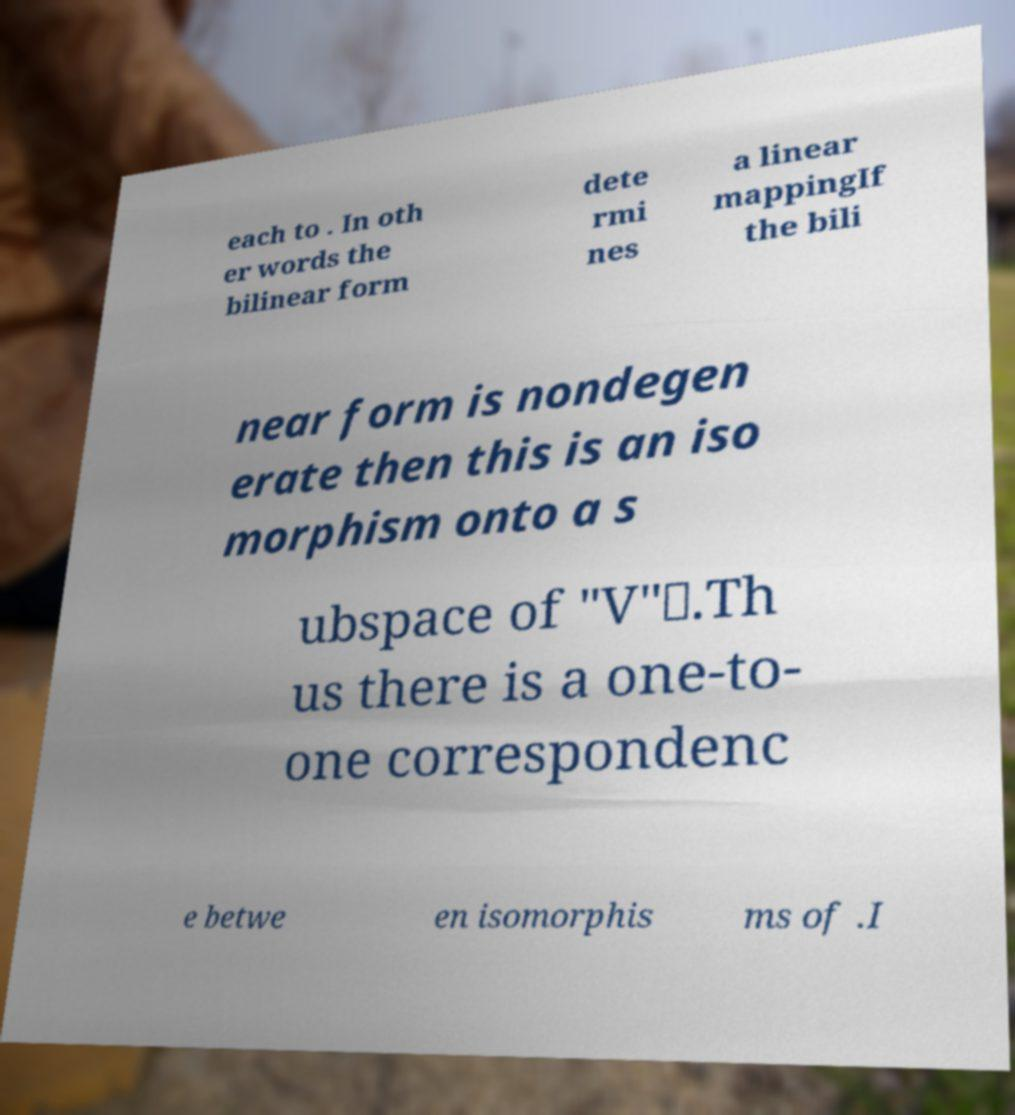For documentation purposes, I need the text within this image transcribed. Could you provide that? each to . In oth er words the bilinear form dete rmi nes a linear mappingIf the bili near form is nondegen erate then this is an iso morphism onto a s ubspace of "V"∗.Th us there is a one-to- one correspondenc e betwe en isomorphis ms of .I 